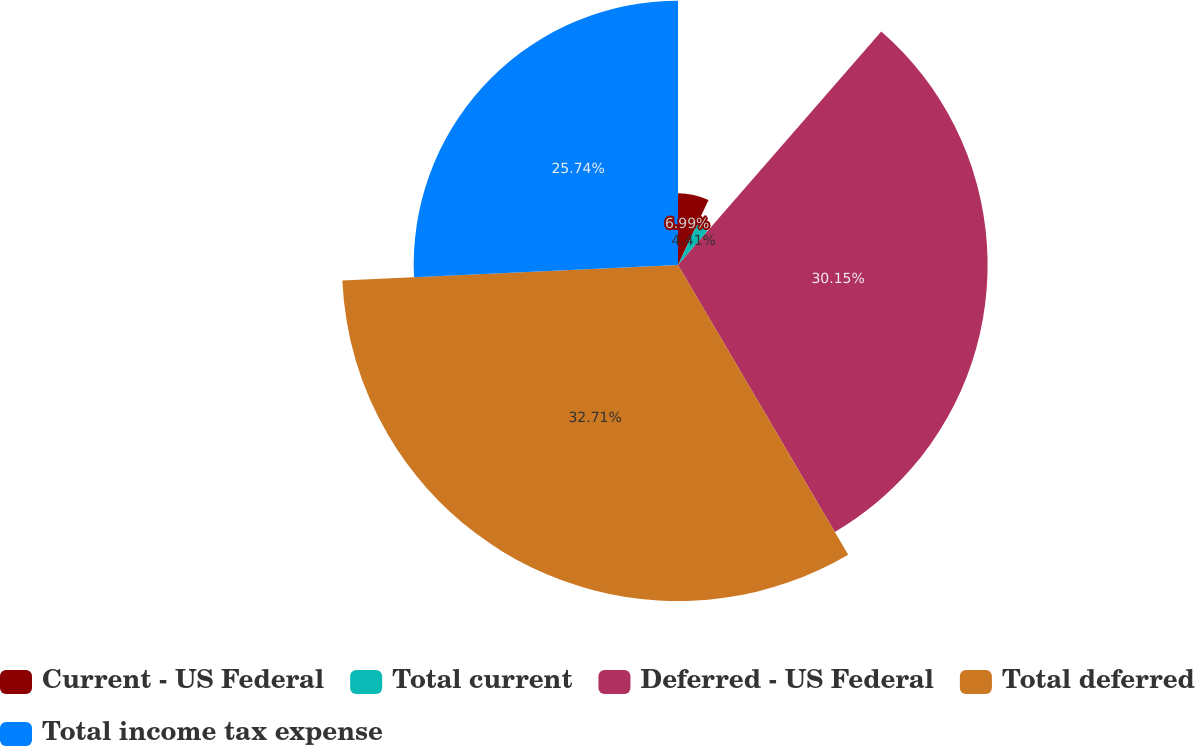<chart> <loc_0><loc_0><loc_500><loc_500><pie_chart><fcel>Current - US Federal<fcel>Total current<fcel>Deferred - US Federal<fcel>Total deferred<fcel>Total income tax expense<nl><fcel>6.99%<fcel>4.41%<fcel>30.15%<fcel>32.72%<fcel>25.74%<nl></chart> 